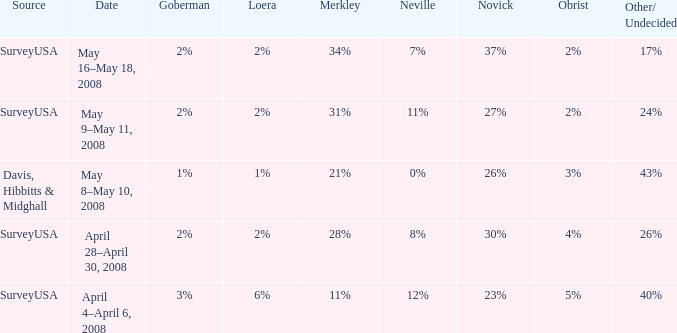Which Loera has a Source of surveyusa, and a Date of may 16–may 18, 2008? 2%. 